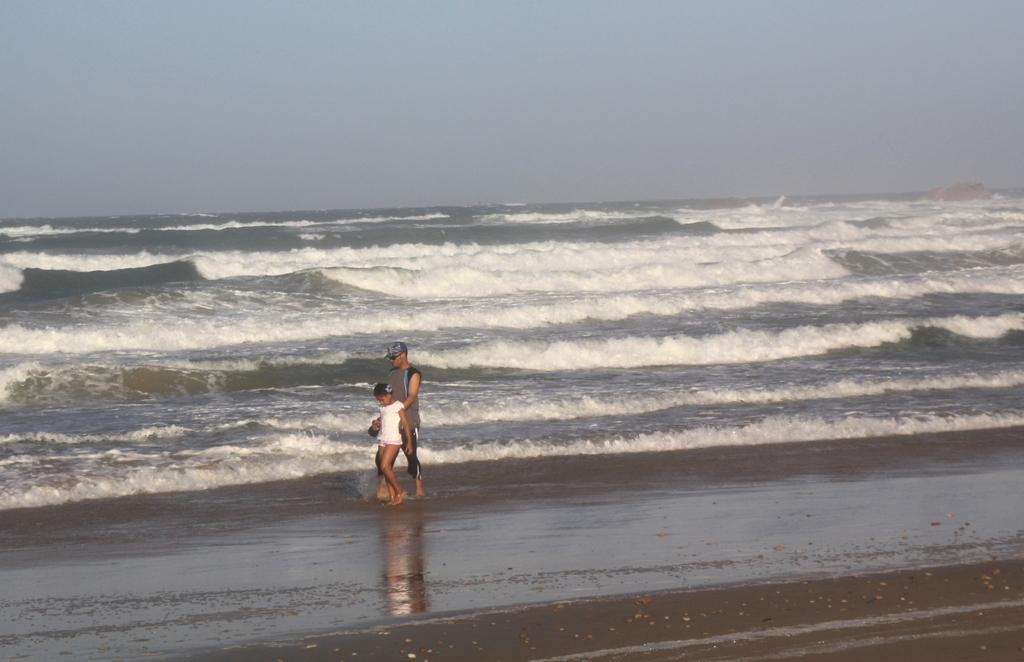Can you describe this image briefly? In this image there is a person and a girl are walking on the land. Person is wearing goggles and cap. Girl is wearing a white dress. Behind them there is water having tides. Top of image there is sky. 